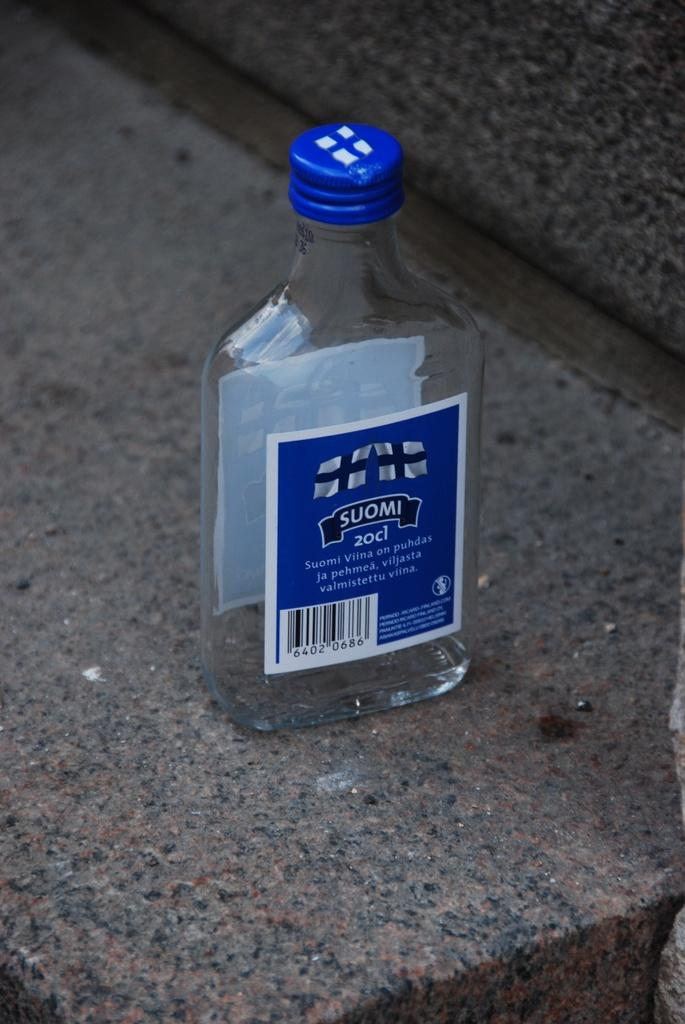<image>
Give a short and clear explanation of the subsequent image. the word suomi is on the back of a bottle 